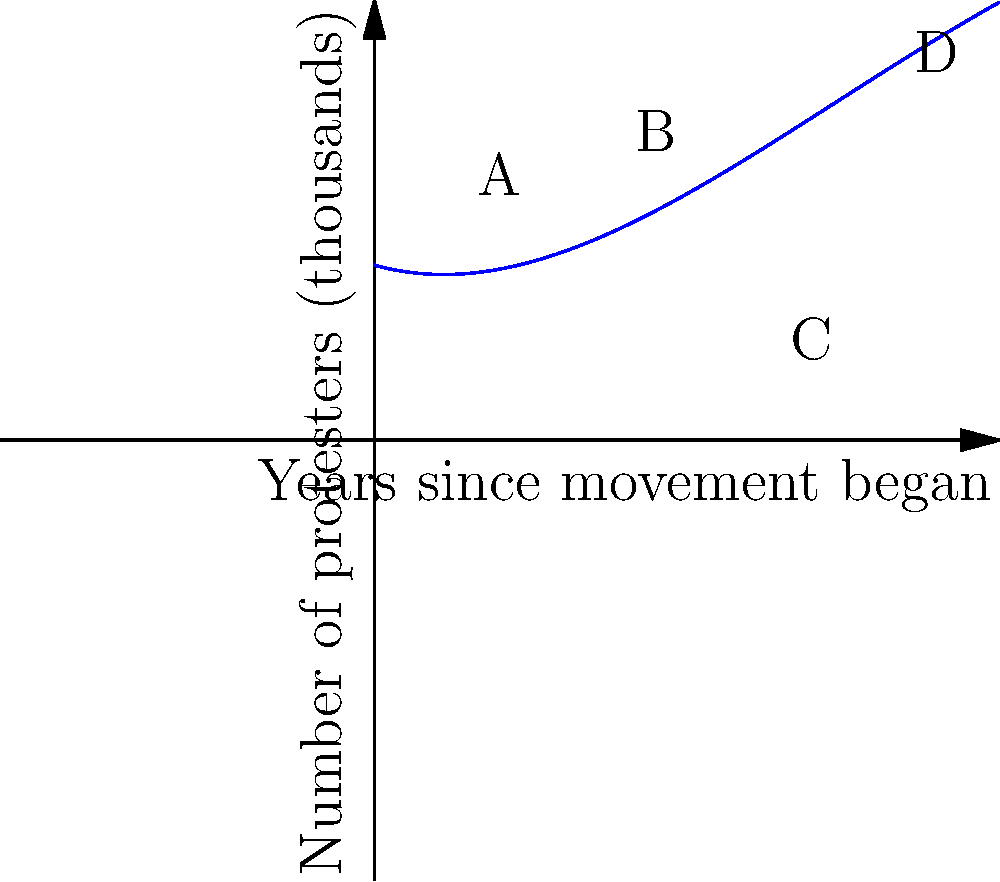The graph represents the number of protesters (in thousands) attending social justice rallies in Morocco over a 10-year period. Identify the number of local maxima and minima in this polynomial function, and explain what they might signify in terms of the movement's progress. To answer this question, we need to analyze the turning points of the graph:

1. Identify local maxima and minima:
   - Local maximum at point A (around year 2)
   - Local minimum at point B (around year 4.5)
   - Local minimum at point C (around year 7)
   - The graph is rising at point D (year 9), suggesting another potential maximum beyond the 10-year period

2. Count the turning points:
   - There are 2 local maxima (A and the implied maximum after D)
   - There are 2 local minima (B and C)

3. Interpret the significance:
   - Local maximum A: Initial surge in protest attendance, possibly due to a catalyzing event
   - Local minimum B: Temporary decline in attendance, perhaps due to government concessions or movement fatigue
   - Local minimum C: Another period of reduced attendance, possibly reflecting setbacks or internal conflicts
   - Rising trend towards D: Resurgence in the movement, potentially due to new issues or renewed energy

The polynomial nature of the graph suggests a complex interplay of factors affecting protest attendance over time, reflecting the ebb and flow of social movements.
Answer: 2 local maxima, 2 local minima; representing fluctuations in movement momentum and public engagement. 